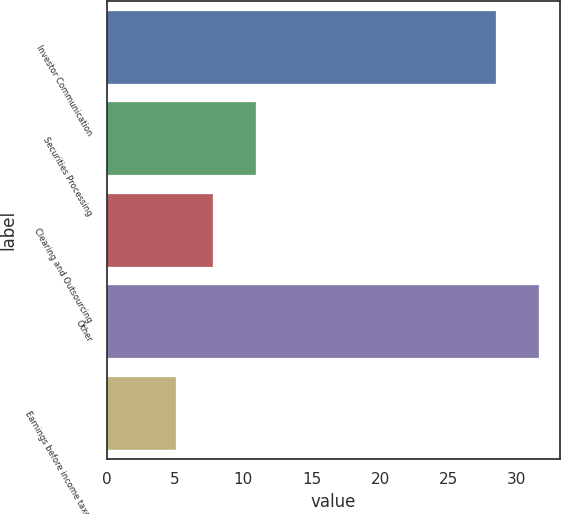<chart> <loc_0><loc_0><loc_500><loc_500><bar_chart><fcel>Investor Communication<fcel>Securities Processing<fcel>Clearing and Outsourcing<fcel>Other<fcel>Earnings before income taxes<nl><fcel>28.5<fcel>10.9<fcel>7.75<fcel>31.6<fcel>5.1<nl></chart> 